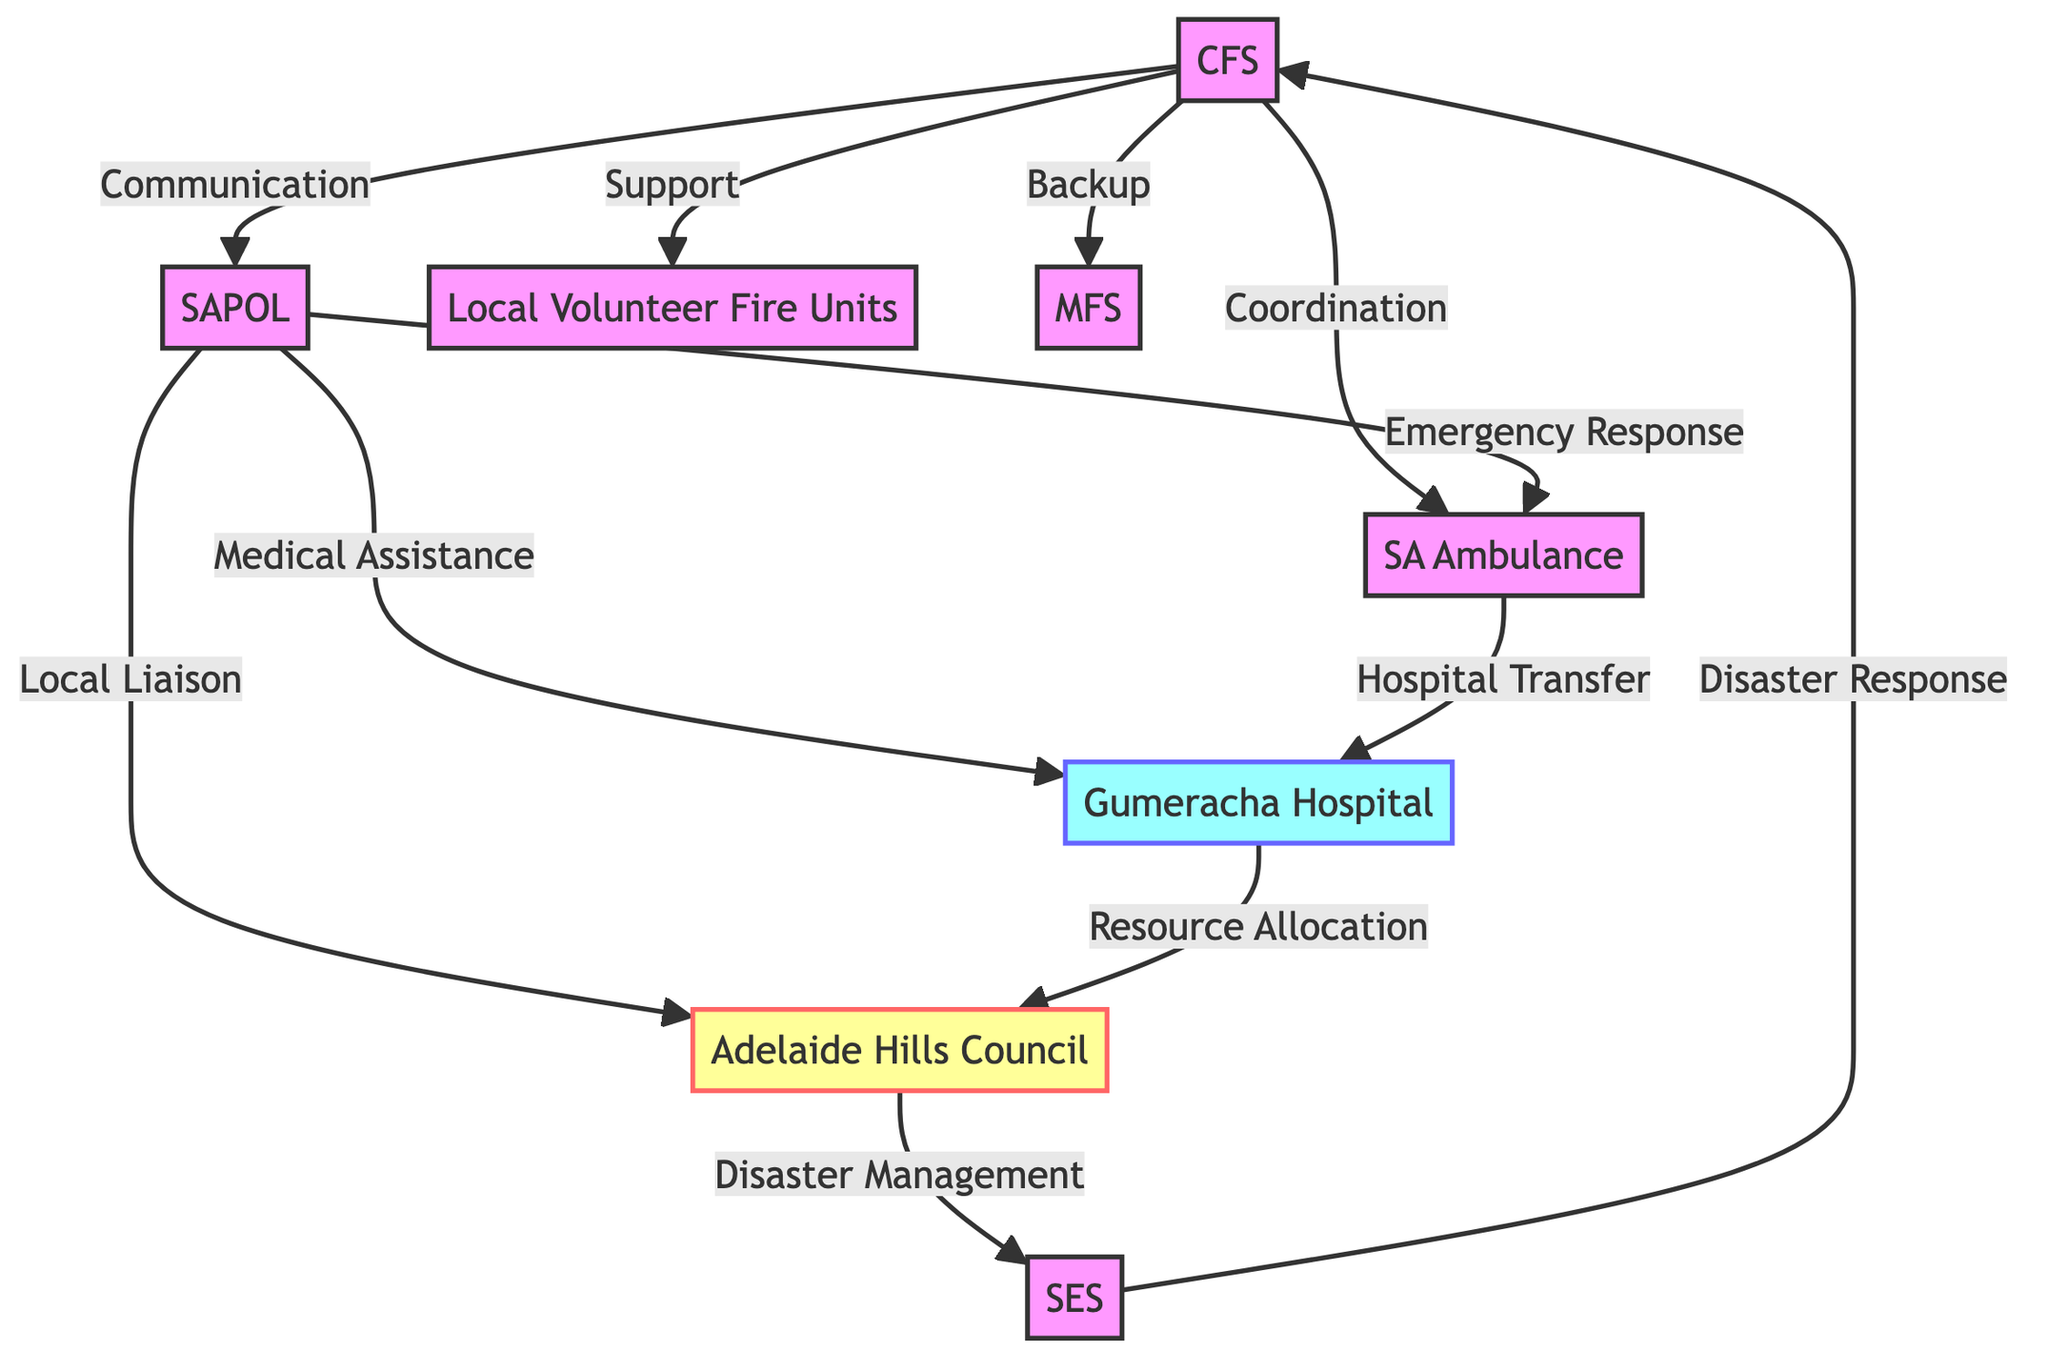What is the total number of nodes in the diagram? The diagram contains a total of 8 nodes, which represent different emergency response teams in the Adelaide Hills region.
Answer: 8 Which node is labeled as Gumeracha Hospital? The node corresponding to Gumeracha Hospital is labeled "4" in the diagram.
Answer: 4 How many edges are connected to the SAPOL (South Australia Police) node? SAPOL has 3 edges connected to it: one to SA Ambulance for Emergency Response, one to Gumeracha Hospital for Medical Assistance Coordination, and one to Adelaide Hills Council for Local Government Liaison.
Answer: 3 What relationship exists between the CFS and SA Ambulance Service? The relationship between CFS and SA Ambulance Service is labeled as a "Coordination Link".
Answer: Coordination Link Which nodes have a direct communication link to the Adelaide Hills Council? The Adelaide Hills Council has direct communication links with SAPOL and SES for Disaster Management.
Answer: SAPOL, SES Which emergency response team provides backup support to the CFS? The Metropolitan Fire Service (MFS) provides backup support to the CFS in the case of emergencies.
Answer: Metropolitan Fire Service What is the primary role of the SES in relation to CFS? The primary role of SES in relation to CFS is Disaster Response, as indicated by the edge connecting the two nodes with the label "Disaster Response".
Answer: Disaster Response Which two nodes are connected by the edge labeled "Hospital Transfer Coordination"? The edge labeled "Hospital Transfer Coordination" connects the SA Ambulance Service node and the Gumeracha Hospital node.
Answer: SA Ambulance Service, Gumeracha Hospital How does the Gumeracha Hospital coordinate resource allocation? Gumeracha Hospital coordinates resource allocation through the edge that connects it to the Adelaide Hills Council, labeled as "Resource Allocation".
Answer: Adelaide Hills Council What type of link exists between Local Volunteer Fire Units and CFS? The link between Local Volunteer Fire Units and CFS is a "Support Link".
Answer: Support Link 